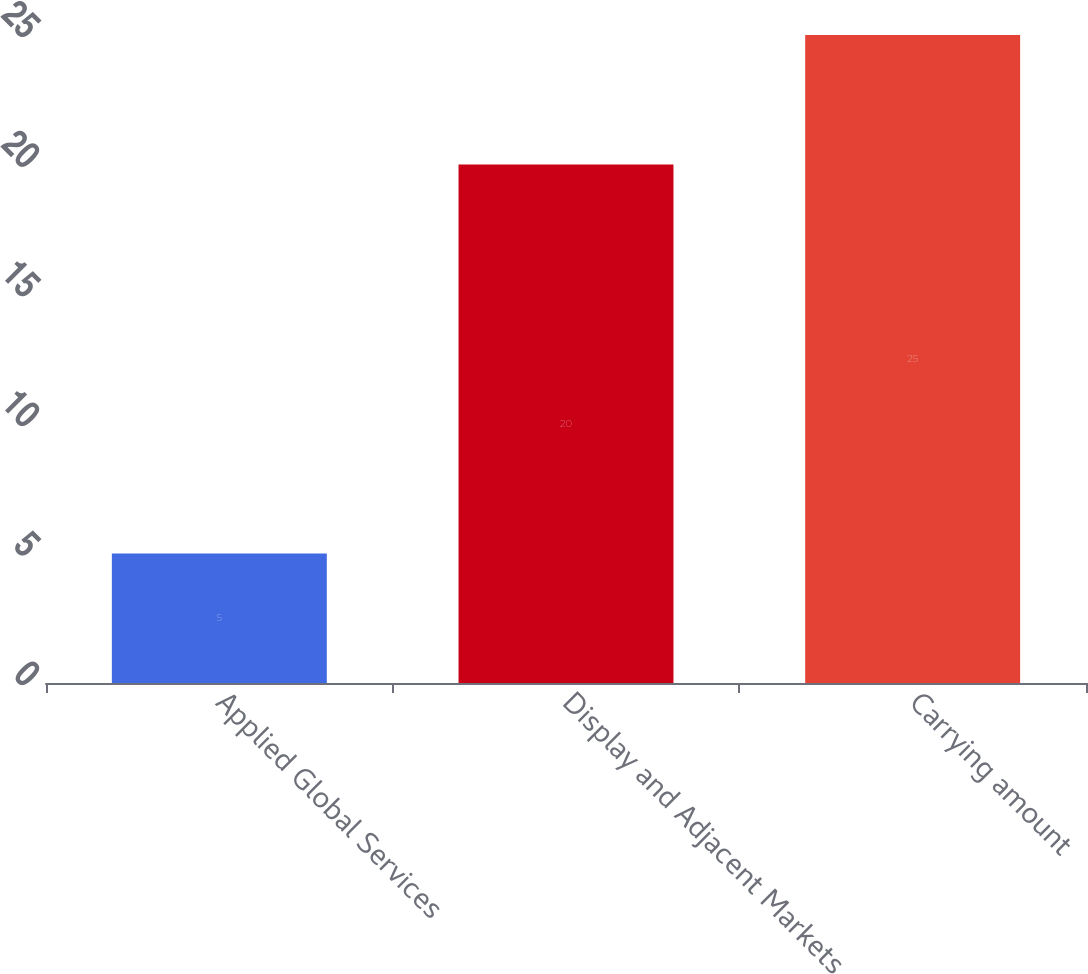Convert chart to OTSL. <chart><loc_0><loc_0><loc_500><loc_500><bar_chart><fcel>Applied Global Services<fcel>Display and Adjacent Markets<fcel>Carrying amount<nl><fcel>5<fcel>20<fcel>25<nl></chart> 